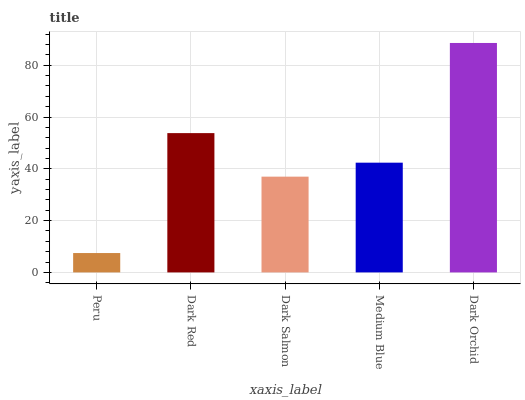Is Dark Red the minimum?
Answer yes or no. No. Is Dark Red the maximum?
Answer yes or no. No. Is Dark Red greater than Peru?
Answer yes or no. Yes. Is Peru less than Dark Red?
Answer yes or no. Yes. Is Peru greater than Dark Red?
Answer yes or no. No. Is Dark Red less than Peru?
Answer yes or no. No. Is Medium Blue the high median?
Answer yes or no. Yes. Is Medium Blue the low median?
Answer yes or no. Yes. Is Peru the high median?
Answer yes or no. No. Is Dark Salmon the low median?
Answer yes or no. No. 